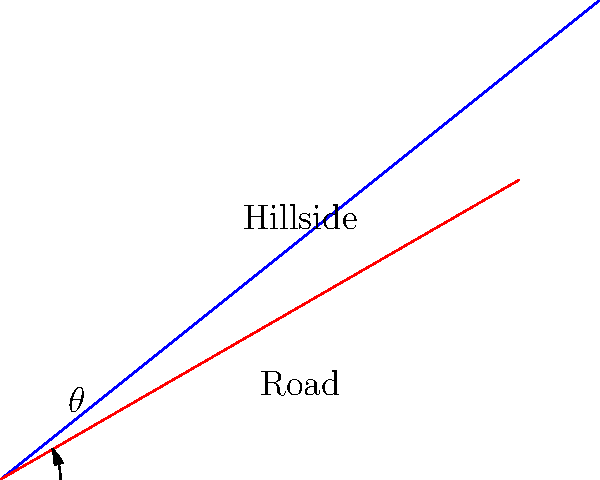As a travel agent recommending local literature, you come across a book about civil engineering in your area. The book discusses the optimal angle for constructing roads on hillsides to minimize erosion. What factor is most crucial in determining this optimal angle $\theta$? To understand the optimal angle for road construction on a hillside to minimize erosion, we need to consider several factors:

1. Slope stability: The angle should be chosen to ensure the slope remains stable and doesn't collapse.

2. Water runoff: The angle affects how water flows down the road during rainfall.

3. Soil type: Different soil types have different erosion resistances and optimal angles.

4. Climate: Local precipitation patterns influence erosion rates.

5. Vegetation: The presence or absence of vegetation affects soil stability.

However, the most crucial factor in determining the optimal angle $\theta$ is the balance between two competing forces:

a) Gravity: As $\theta$ increases, the component of gravitational force parallel to the road surface increases, potentially accelerating erosion.

b) Water velocity: As $\theta$ decreases, water flows more slowly down the road, allowing more time for infiltration and potentially increasing erosion.

The optimal angle is one that minimizes the combined effect of these forces. This angle is typically calculated using the equation:

$$\tan \theta = \frac{1}{2} \tan \beta$$

Where $\beta$ is the natural angle of repose of the soil.

This equation balances the effects of gravity and water velocity to minimize erosion.
Answer: Balance between gravitational force and water velocity 